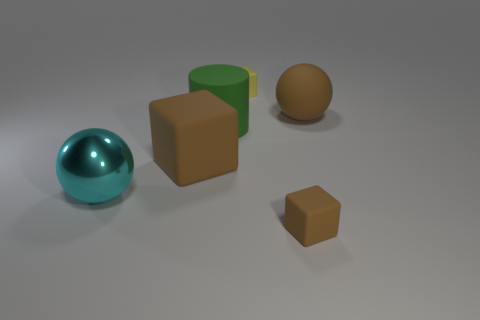Add 3 matte cubes. How many objects exist? 9 Subtract all balls. How many objects are left? 4 Add 5 brown blocks. How many brown blocks are left? 7 Add 2 yellow matte blocks. How many yellow matte blocks exist? 3 Subtract 0 gray spheres. How many objects are left? 6 Subtract all green matte cylinders. Subtract all cylinders. How many objects are left? 4 